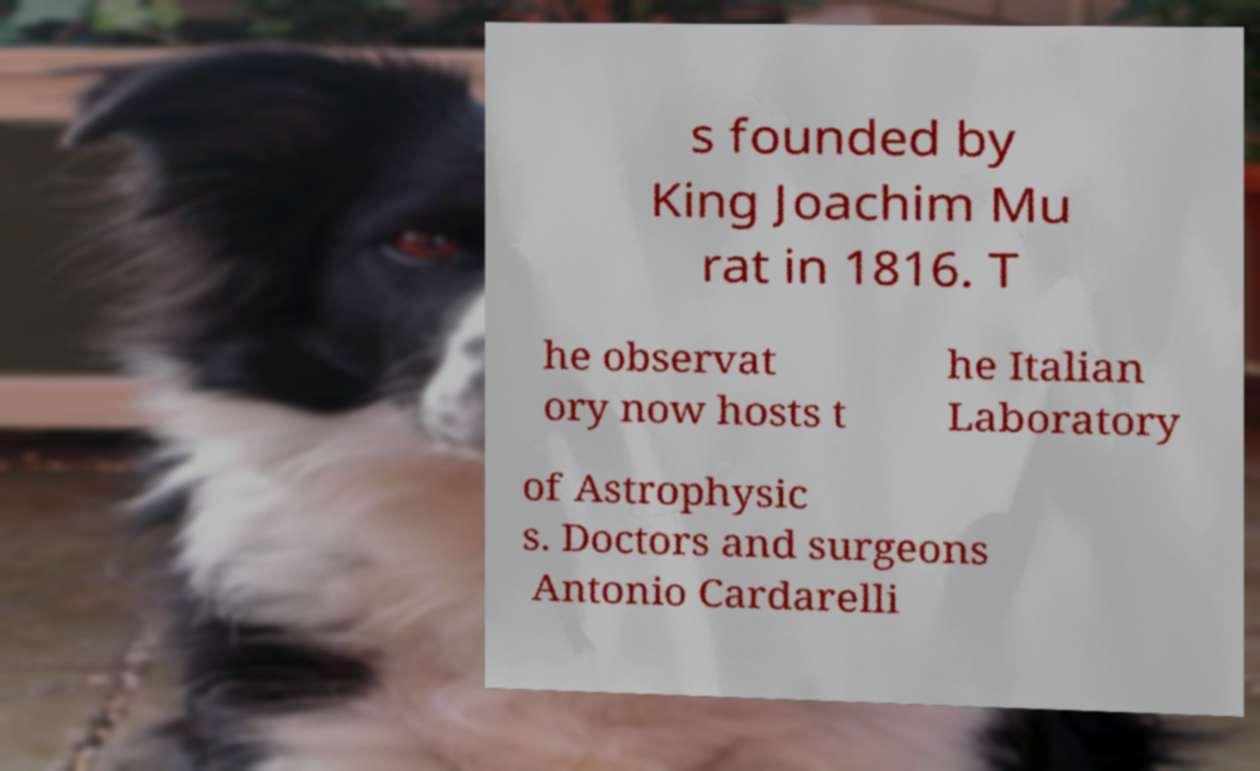Please identify and transcribe the text found in this image. s founded by King Joachim Mu rat in 1816. T he observat ory now hosts t he Italian Laboratory of Astrophysic s. Doctors and surgeons Antonio Cardarelli 